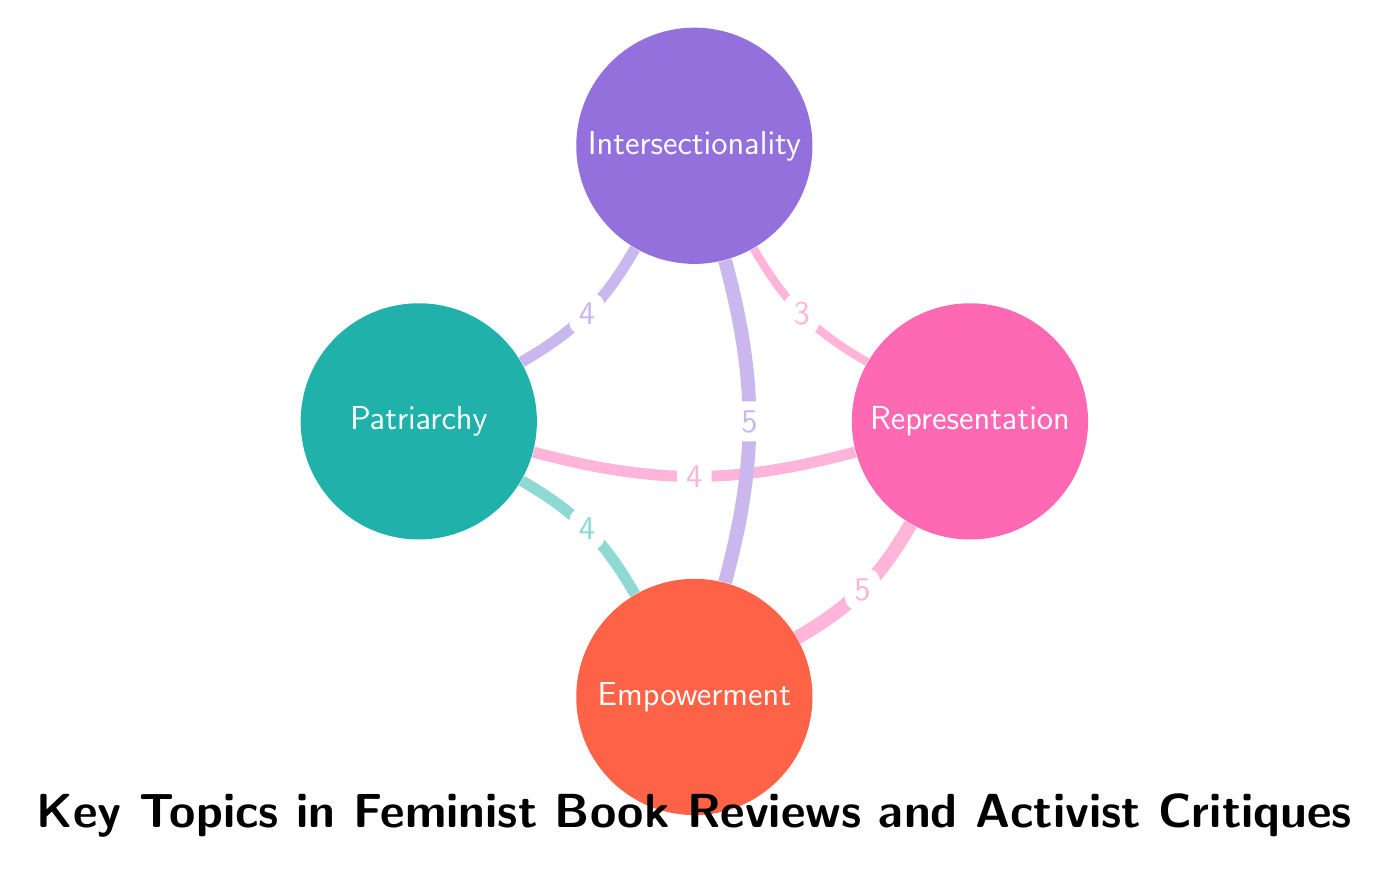What are the four key topics represented in the diagram? The diagram specifically lists four topics: Representation, Intersectionality, Patriarchy, and Empowerment. These are visually represented as nodes in the chord diagram.
Answer: Representation, Intersectionality, Patriarchy, Empowerment Which link has the highest value? By examining the thickness of the links in the diagram, the link between Representation and Empowerment has the highest value of 5, indicating a strong connection.
Answer: Representation and Empowerment How many links are there in total? The total number of links can be counted in the diagram, and there are six distinct links connecting the nodes with various values.
Answer: 6 What is the value of the link between Intersectionality and Patriarchy? The value of the link connecting Intersectionality to Patriarchy is visible in the diagram and is identified as 4, indicating the strength of their relationship.
Answer: 4 Which two nodes have the strongest connection? To determine which nodes have the strongest connection, we look at the values of the links; the strongest connection is between Representation and Empowerment with a value of 5.
Answer: Representation and Empowerment What is the value of the link between Representation and Intersectionality? The link connecting Representation and Intersectionality has a value of 3, as shown in the diagram. This represents a moderate connection between the two concepts.
Answer: 3 Which nodes are connected through a link valued at 5? The only nodes connected by a link with a value of 5 are Representation and Empowerment, demonstrating their significant relationship in the context of feminist critiques.
Answer: Representation and Empowerment Which node is connected to all other nodes? By analyzing the connections, it is clear that Representation is connected to all other nodes: Intersectionality, Patriarchy, and Empowerment.
Answer: Representation 